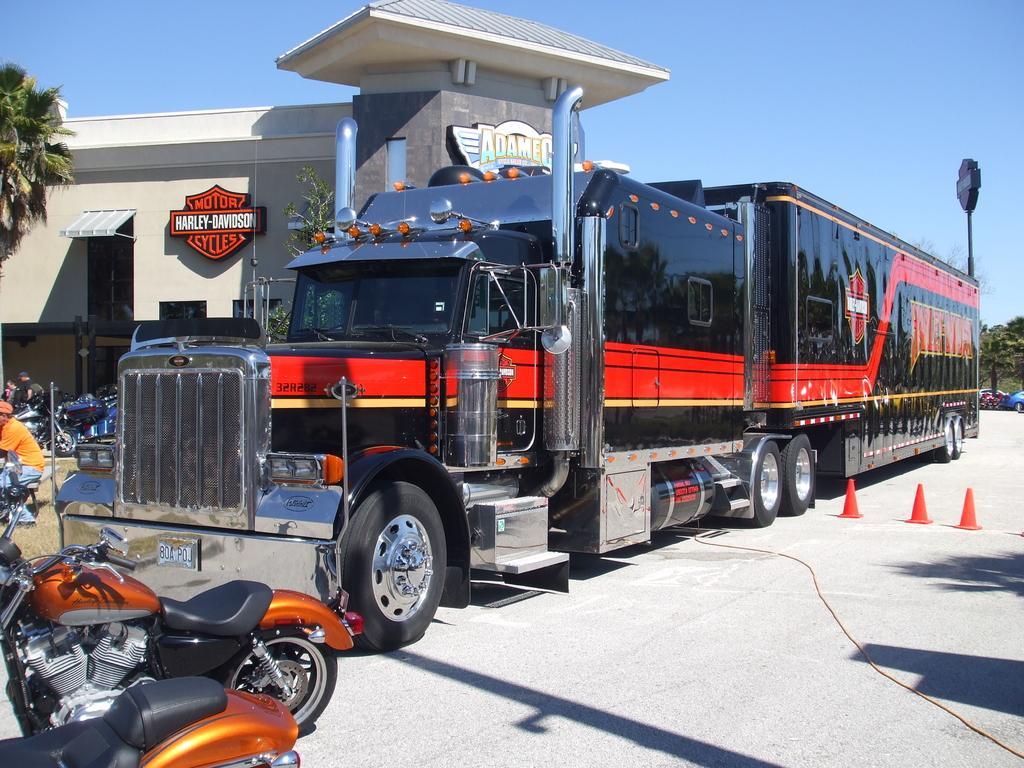Could you give a brief overview of what you see in this image? In this image I can see a black color vehicle on the road which is facing towards the left side. In front of this there are some bikes and I can see a person wearing orange color t-shirt and sitting on a bench. In the background there is a building and a tree. On the right side, I can see some trees and a pole. On the top of the image I can see the sky. 